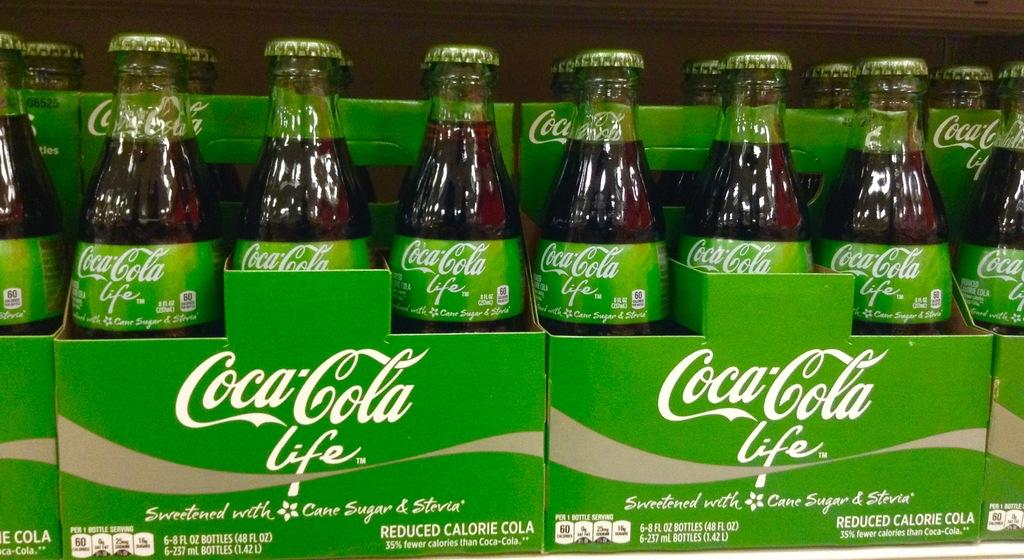What type of bottles are present in the image? There are Coca Cola bottles in the image. What can be seen on the Coca Cola bottles? The Coca Cola bottles have labels on them. How are the Coca Cola bottles arranged in the image? The Coca Cola bottles are placed in green color boxes. What type of mark can be seen on the town in the image? There is no town present in the image, so there is no mark to be seen. 